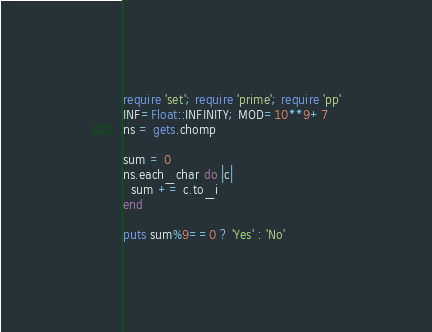<code> <loc_0><loc_0><loc_500><loc_500><_Ruby_>require 'set'; require 'prime'; require 'pp'
INF=Float::INFINITY; MOD=10**9+7
ns = gets.chomp

sum = 0
ns.each_char do |c|
  sum += c.to_i
end

puts sum%9==0 ? 'Yes' : 'No'</code> 